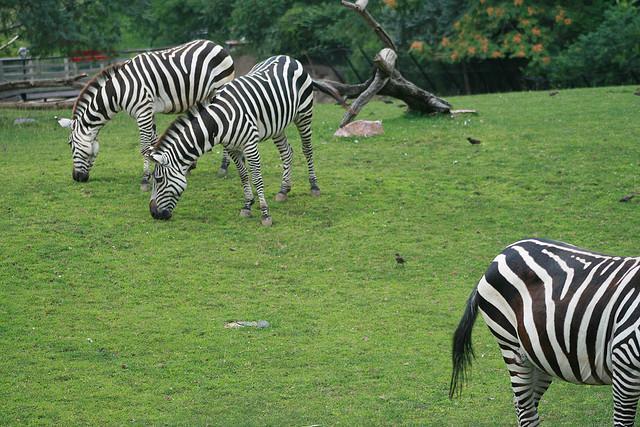How many zebras can you see eating?
Give a very brief answer. 2. How many zebras are there?
Give a very brief answer. 3. 